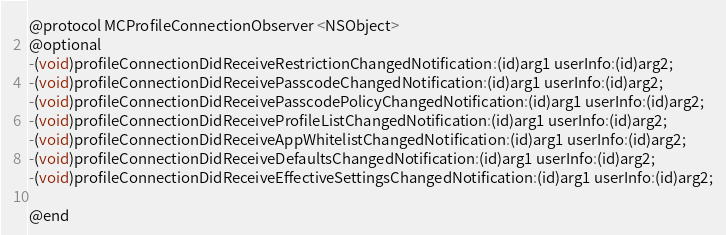Convert code to text. <code><loc_0><loc_0><loc_500><loc_500><_C_>@protocol MCProfileConnectionObserver <NSObject>
@optional
-(void)profileConnectionDidReceiveRestrictionChangedNotification:(id)arg1 userInfo:(id)arg2;
-(void)profileConnectionDidReceivePasscodeChangedNotification:(id)arg1 userInfo:(id)arg2;
-(void)profileConnectionDidReceivePasscodePolicyChangedNotification:(id)arg1 userInfo:(id)arg2;
-(void)profileConnectionDidReceiveProfileListChangedNotification:(id)arg1 userInfo:(id)arg2;
-(void)profileConnectionDidReceiveAppWhitelistChangedNotification:(id)arg1 userInfo:(id)arg2;
-(void)profileConnectionDidReceiveDefaultsChangedNotification:(id)arg1 userInfo:(id)arg2;
-(void)profileConnectionDidReceiveEffectiveSettingsChangedNotification:(id)arg1 userInfo:(id)arg2;

@end

</code> 